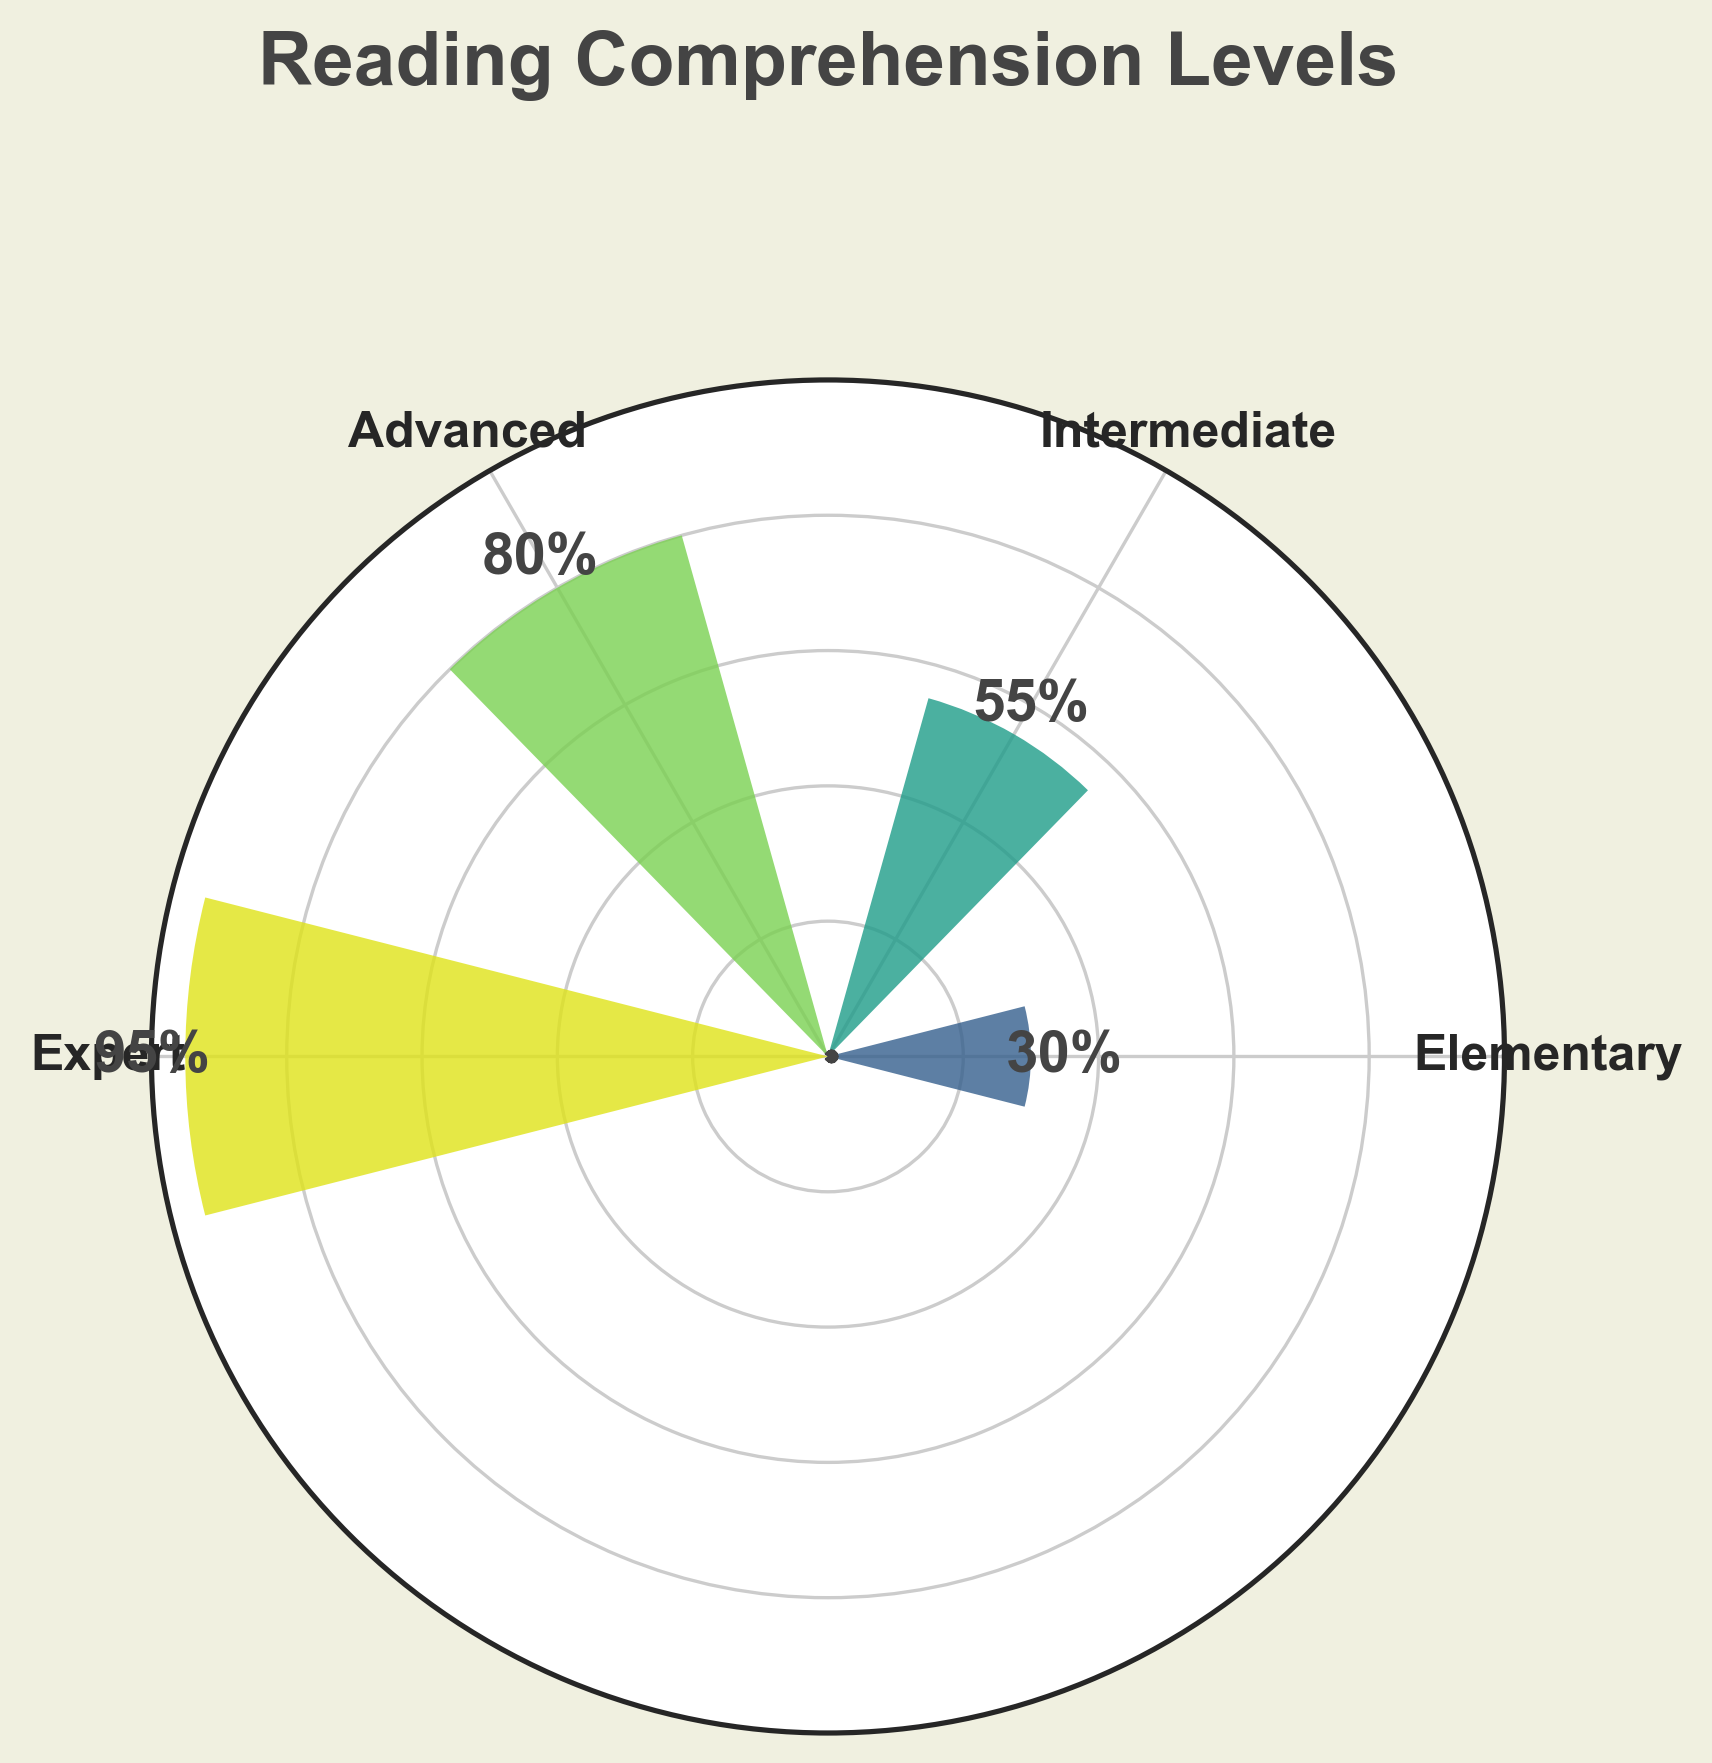What's the highest reading comprehension level presented in the chart? The highest value should be the largest score shown on the gauge chart. The chart indicates that the highest score is for the "Expert" level with a score of 95.
Answer: Expert What is the range of reading comprehension scores among book club members? To find the range, subtract the minimum score from the maximum score. The range is: 95 (Expert) - 30 (Elementary) = 65.
Answer: 65 Which reading comprehension level has the lowest score? Identify the level associated with the smallest score in the gauge chart. The chart shows that the "Elementary" level has the lowest score of 30.
Answer: Elementary How many reading comprehension levels are evaluated in the chart? Count the number of different reading levels listed in the chart's labels. The chart features four distinct reading levels: Elementary, Intermediate, Advanced, and Expert.
Answer: 4 What is the average score of the reading comprehension levels? To calculate the average, sum all the scores and divide by the number of levels: (30 + 55 + 80 + 95) / 4. The sum of the scores is 260. Dividing by 4 gives the average: 260 / 4 = 65.
Answer: 65 Which level shows a score closest to the average score of all levels? First, find the average score, which is 65. Compare each level's score to see which one is closest. Intermediate has a score of 55, which is closest to the average score of 65.
Answer: Intermediate How much higher is the Advanced level score compared to the Elementary level score? Subtract the Elementary score from the Advanced score: 80 (Advanced) - 30 (Elementary) = 50.
Answer: 50 What is the difference between the highest and the third highest scores? The highest score is 95 (Expert) and the third highest score is 55 (Intermediate). Calculate the difference: 95 - 55 = 40.
Answer: 40 